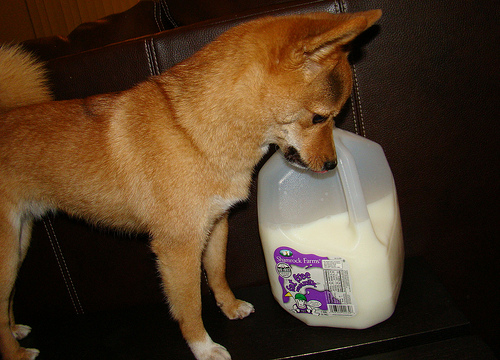<image>
Is the puppy above the bottle? Yes. The puppy is positioned above the bottle in the vertical space, higher up in the scene. 